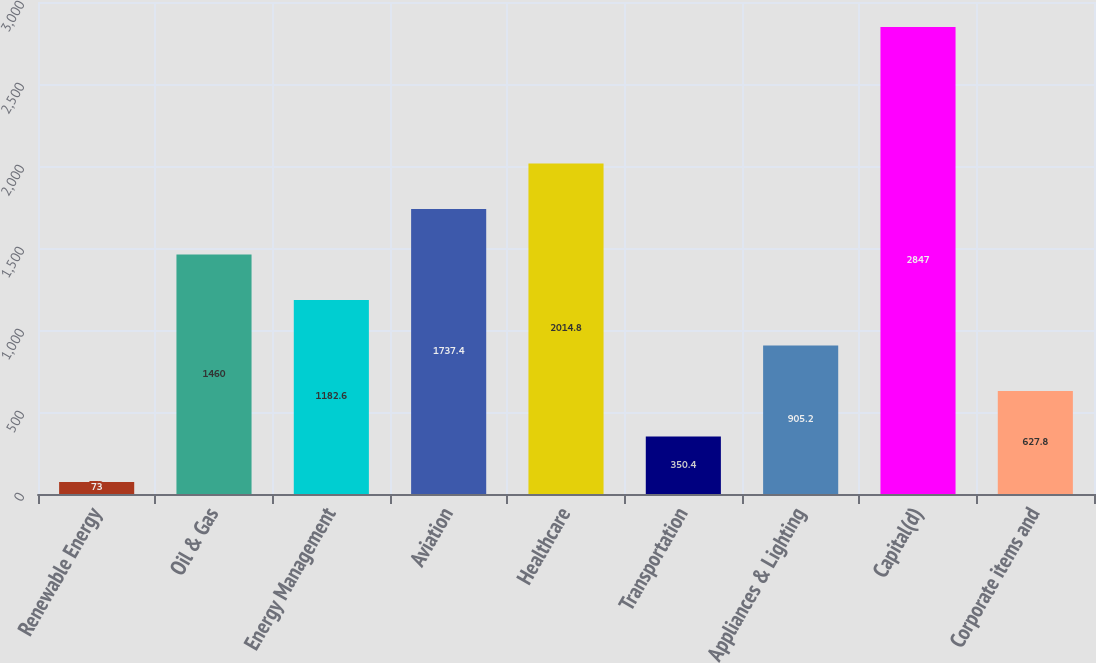Convert chart. <chart><loc_0><loc_0><loc_500><loc_500><bar_chart><fcel>Renewable Energy<fcel>Oil & Gas<fcel>Energy Management<fcel>Aviation<fcel>Healthcare<fcel>Transportation<fcel>Appliances & Lighting<fcel>Capital(d)<fcel>Corporate items and<nl><fcel>73<fcel>1460<fcel>1182.6<fcel>1737.4<fcel>2014.8<fcel>350.4<fcel>905.2<fcel>2847<fcel>627.8<nl></chart> 